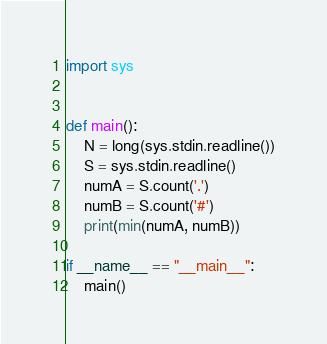<code> <loc_0><loc_0><loc_500><loc_500><_Python_>import sys


def main():
    N = long(sys.stdin.readline())
    S = sys.stdin.readline()
    numA = S.count('.')
    numB = S.count('#')
    print(min(numA, numB))

if __name__ == "__main__":
    main()
</code> 